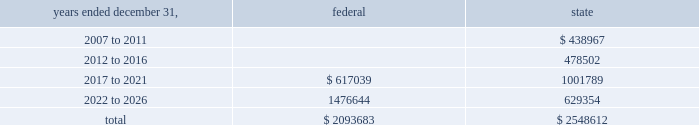American tower corporation and subsidiaries notes to consolidated financial statements 2014 ( continued ) basis step-up from corporate restructuring represents the tax effects of increasing the basis for tax purposes of certain of the company 2019s assets in conjunction with its spin-off from american radio systems corporation , its former parent company .
At december 31 , 2006 , the company had net federal and state operating loss carryforwards available to reduce future taxable income of approximately $ 2.1 billion and $ 2.5 billion , respectively .
If not utilized , the company 2019s net operating loss carryforwards expire as follows ( in thousands ) : .
Sfas no .
109 , 201caccounting for income taxes , 201d requires that companies record a valuation allowance when it is 201cmore likely than not that some portion or all of the deferred tax assets will not be realized . 201d at december 31 , 2006 , the company has provided a valuation allowance of approximately $ 308.2 million , including approximately $ 153.6 million attributable to spectrasite , primarily related to net operating loss and capital loss carryforwards assumed as of the acquisition date .
The balance of the valuation allowance primarily relates to net state deferred tax assets .
The company has not provided a valuation allowance for the remaining deferred tax assets , primarily its federal net operating loss carryforwards , as management believes the company will have sufficient time to realize these federal net operating loss carryforwards during the twenty-year tax carryforward period .
Valuation allowances may be reversed if related deferred tax assets are deemed realizable based on changes in facts and circumstances relevant to the assets 2019 recoverability .
Approximately $ 148.3 million of the spectrasite valuation allowances as of december 31 , 2006 will be recorded as a reduction to goodwill if the underlying deferred tax assets are utilized .
The company intends to recover a portion of its deferred tax asset through its federal income tax refund claims related to the carry back of certain federal net operating losses .
In june 2003 and october 2003 , the company filed federal income tax refund claims with the irs relating to the carry back of $ 380.0 million of net operating losses generated prior to 2003 , of which the company initially anticipated receiving approximately $ 90.0 million .
Based on preliminary discussions with tax authorities , the company revised its estimate of the net realizable value of the federal income tax refund claims during the year ended december 31 , 2005 , and anticipates receiving a refund of approximately $ 65.0 million , plus interest .
The company expects settlement of this matter in the first half of 2007 , however , there can be no assurances with respect to the timing of any refund .
Because of the uncertainty associated with the claim , the company has not recognized any amounts related to interest .
The recoverability of the company 2019s remaining net deferred tax asset has been assessed utilizing stable state ( no growth ) projections based on its current operations .
The projections show a significant decrease in depreciation in the later years of the carryforward period as a result of a significant portion of its assets being fully depreciated during the first fifteen years of the carryforward period .
Accordingly , the recoverability of the net deferred tax asset is not dependent on material improvements to operations , material asset sales or other non-routine transactions .
Based on its current outlook of future taxable income during the carryforward period , management believes that the net deferred tax asset will be realized .
The realization of the company 2019s deferred tax assets as of december 31 , 2006 will be dependent upon its ability to generate approximately $ 1.4 billion in taxable income from january 1 , 2007 to december 31 , 2026 .
If the company is unable to generate sufficient taxable income in the future , or carry back losses , as described above , it .
What portion of state operating loss carryforwards expire between 2007 and 2011? 
Computations: (438967 / 2548612)
Answer: 0.17224. American tower corporation and subsidiaries notes to consolidated financial statements 2014 ( continued ) basis step-up from corporate restructuring represents the tax effects of increasing the basis for tax purposes of certain of the company 2019s assets in conjunction with its spin-off from american radio systems corporation , its former parent company .
At december 31 , 2006 , the company had net federal and state operating loss carryforwards available to reduce future taxable income of approximately $ 2.1 billion and $ 2.5 billion , respectively .
If not utilized , the company 2019s net operating loss carryforwards expire as follows ( in thousands ) : .
Sfas no .
109 , 201caccounting for income taxes , 201d requires that companies record a valuation allowance when it is 201cmore likely than not that some portion or all of the deferred tax assets will not be realized . 201d at december 31 , 2006 , the company has provided a valuation allowance of approximately $ 308.2 million , including approximately $ 153.6 million attributable to spectrasite , primarily related to net operating loss and capital loss carryforwards assumed as of the acquisition date .
The balance of the valuation allowance primarily relates to net state deferred tax assets .
The company has not provided a valuation allowance for the remaining deferred tax assets , primarily its federal net operating loss carryforwards , as management believes the company will have sufficient time to realize these federal net operating loss carryforwards during the twenty-year tax carryforward period .
Valuation allowances may be reversed if related deferred tax assets are deemed realizable based on changes in facts and circumstances relevant to the assets 2019 recoverability .
Approximately $ 148.3 million of the spectrasite valuation allowances as of december 31 , 2006 will be recorded as a reduction to goodwill if the underlying deferred tax assets are utilized .
The company intends to recover a portion of its deferred tax asset through its federal income tax refund claims related to the carry back of certain federal net operating losses .
In june 2003 and october 2003 , the company filed federal income tax refund claims with the irs relating to the carry back of $ 380.0 million of net operating losses generated prior to 2003 , of which the company initially anticipated receiving approximately $ 90.0 million .
Based on preliminary discussions with tax authorities , the company revised its estimate of the net realizable value of the federal income tax refund claims during the year ended december 31 , 2005 , and anticipates receiving a refund of approximately $ 65.0 million , plus interest .
The company expects settlement of this matter in the first half of 2007 , however , there can be no assurances with respect to the timing of any refund .
Because of the uncertainty associated with the claim , the company has not recognized any amounts related to interest .
The recoverability of the company 2019s remaining net deferred tax asset has been assessed utilizing stable state ( no growth ) projections based on its current operations .
The projections show a significant decrease in depreciation in the later years of the carryforward period as a result of a significant portion of its assets being fully depreciated during the first fifteen years of the carryforward period .
Accordingly , the recoverability of the net deferred tax asset is not dependent on material improvements to operations , material asset sales or other non-routine transactions .
Based on its current outlook of future taxable income during the carryforward period , management believes that the net deferred tax asset will be realized .
The realization of the company 2019s deferred tax assets as of december 31 , 2006 will be dependent upon its ability to generate approximately $ 1.4 billion in taxable income from january 1 , 2007 to december 31 , 2026 .
If the company is unable to generate sufficient taxable income in the future , or carry back losses , as described above , it .
At december 31 , 2006 what was the percent of the total company nol set to expire between 2017 and 2021? 
Computations: (617039 / 2093683)
Answer: 0.29471. 